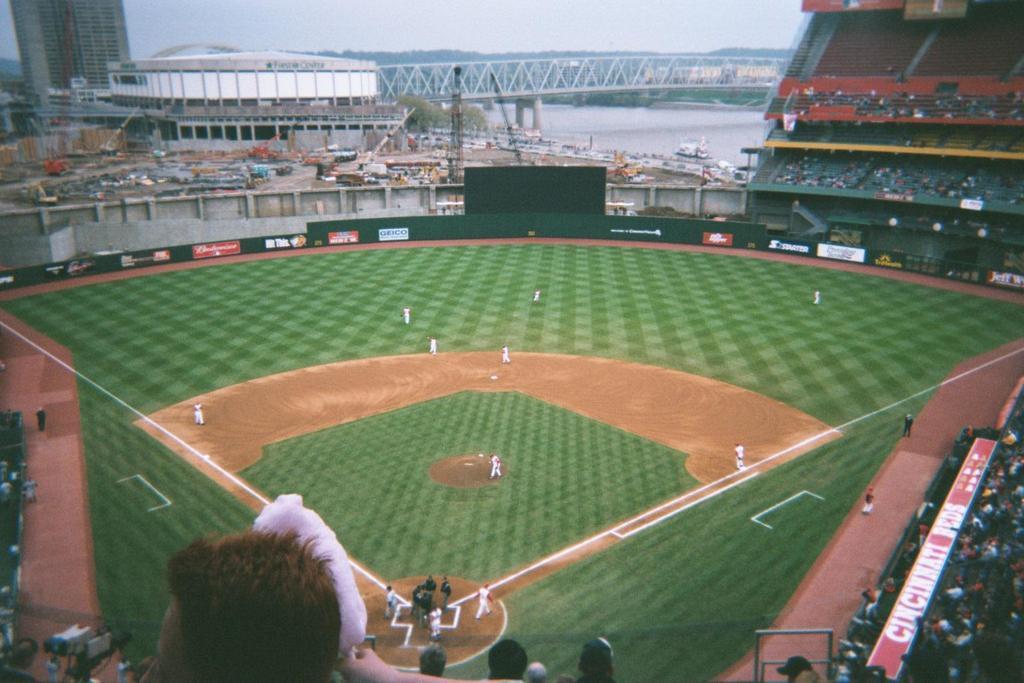Could you give a brief overview of what you see in this image? This picture describes about group of people, few people playing game in the ground, in the background we can see few hoardings, buildings, vehicles and a bridge over the water, in the bottom right hand corner we can see a camera. 